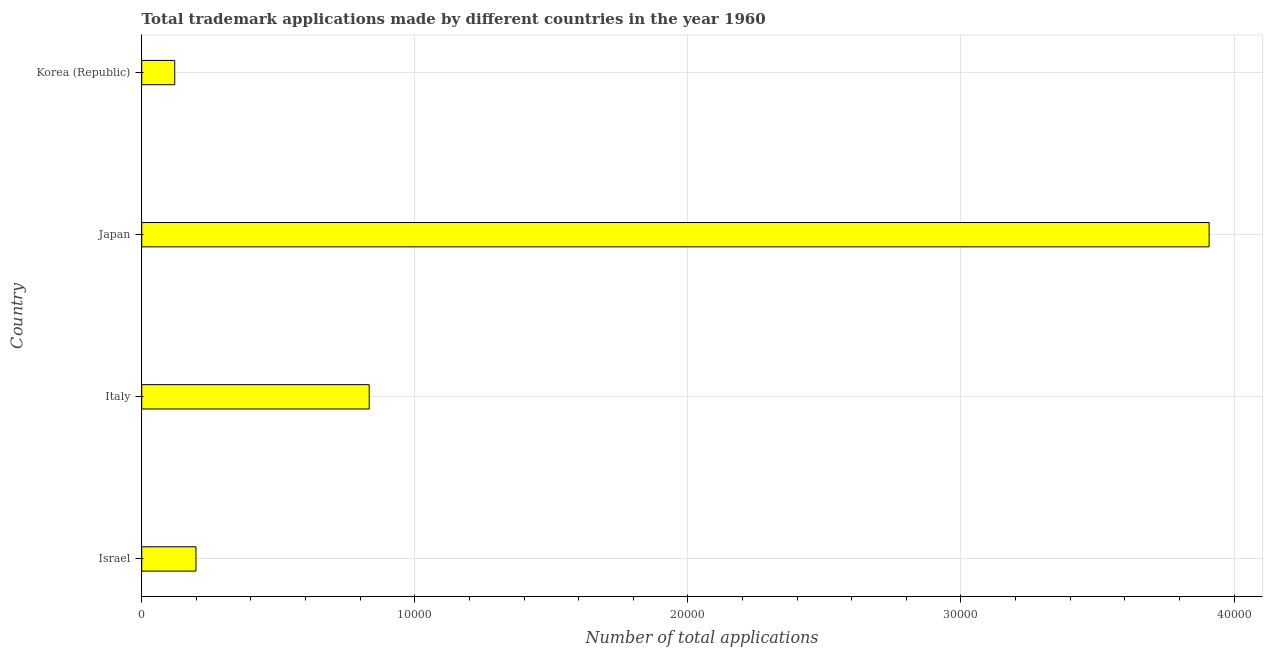Does the graph contain any zero values?
Keep it short and to the point. No. Does the graph contain grids?
Provide a short and direct response. Yes. What is the title of the graph?
Your answer should be very brief. Total trademark applications made by different countries in the year 1960. What is the label or title of the X-axis?
Offer a terse response. Number of total applications. What is the number of trademark applications in Korea (Republic)?
Your answer should be very brief. 1209. Across all countries, what is the maximum number of trademark applications?
Offer a terse response. 3.91e+04. Across all countries, what is the minimum number of trademark applications?
Give a very brief answer. 1209. In which country was the number of trademark applications maximum?
Your answer should be compact. Japan. In which country was the number of trademark applications minimum?
Your response must be concise. Korea (Republic). What is the sum of the number of trademark applications?
Offer a terse response. 5.06e+04. What is the difference between the number of trademark applications in Israel and Japan?
Keep it short and to the point. -3.71e+04. What is the average number of trademark applications per country?
Your response must be concise. 1.27e+04. What is the median number of trademark applications?
Your answer should be compact. 5158.5. In how many countries, is the number of trademark applications greater than 26000 ?
Your response must be concise. 1. What is the ratio of the number of trademark applications in Israel to that in Korea (Republic)?
Offer a terse response. 1.64. Is the number of trademark applications in Israel less than that in Korea (Republic)?
Your response must be concise. No. What is the difference between the highest and the second highest number of trademark applications?
Offer a very short reply. 3.08e+04. What is the difference between the highest and the lowest number of trademark applications?
Provide a succinct answer. 3.79e+04. In how many countries, is the number of trademark applications greater than the average number of trademark applications taken over all countries?
Make the answer very short. 1. Are all the bars in the graph horizontal?
Keep it short and to the point. Yes. What is the Number of total applications of Israel?
Offer a very short reply. 1986. What is the Number of total applications in Italy?
Your answer should be very brief. 8331. What is the Number of total applications of Japan?
Provide a succinct answer. 3.91e+04. What is the Number of total applications of Korea (Republic)?
Your response must be concise. 1209. What is the difference between the Number of total applications in Israel and Italy?
Your answer should be very brief. -6345. What is the difference between the Number of total applications in Israel and Japan?
Provide a short and direct response. -3.71e+04. What is the difference between the Number of total applications in Israel and Korea (Republic)?
Offer a terse response. 777. What is the difference between the Number of total applications in Italy and Japan?
Offer a very short reply. -3.08e+04. What is the difference between the Number of total applications in Italy and Korea (Republic)?
Offer a terse response. 7122. What is the difference between the Number of total applications in Japan and Korea (Republic)?
Give a very brief answer. 3.79e+04. What is the ratio of the Number of total applications in Israel to that in Italy?
Your answer should be compact. 0.24. What is the ratio of the Number of total applications in Israel to that in Japan?
Offer a terse response. 0.05. What is the ratio of the Number of total applications in Israel to that in Korea (Republic)?
Make the answer very short. 1.64. What is the ratio of the Number of total applications in Italy to that in Japan?
Provide a short and direct response. 0.21. What is the ratio of the Number of total applications in Italy to that in Korea (Republic)?
Ensure brevity in your answer.  6.89. What is the ratio of the Number of total applications in Japan to that in Korea (Republic)?
Your answer should be compact. 32.33. 